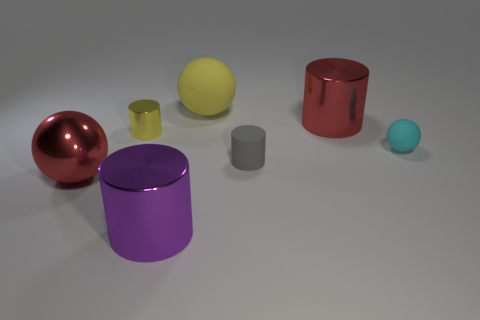Subtract all big balls. How many balls are left? 1 Add 2 yellow metal objects. How many objects exist? 9 Subtract all red balls. How many balls are left? 2 Subtract 1 spheres. How many spheres are left? 2 Subtract all tiny green metal things. Subtract all large red objects. How many objects are left? 5 Add 2 tiny metallic cylinders. How many tiny metallic cylinders are left? 3 Add 7 big red balls. How many big red balls exist? 8 Subtract 1 red cylinders. How many objects are left? 6 Subtract all cylinders. How many objects are left? 3 Subtract all blue spheres. Subtract all cyan blocks. How many spheres are left? 3 